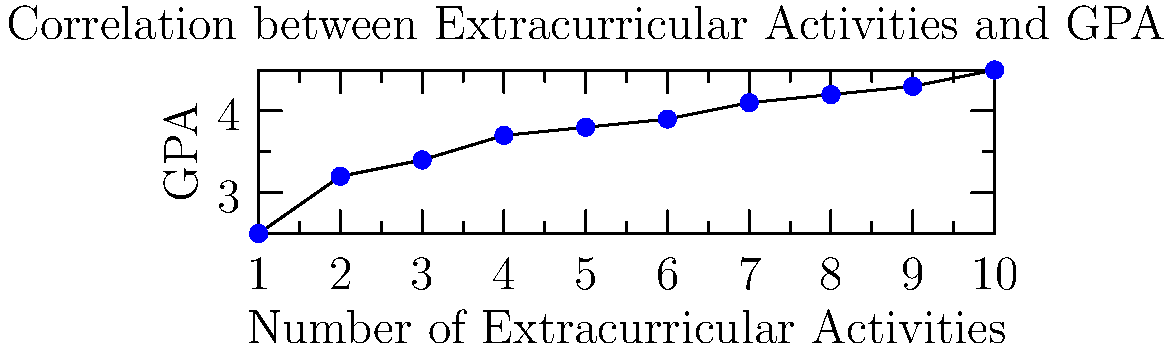As a school counselor analyzing the impact of popular culture on student behavior, you come across a scatter plot showing the relationship between the number of extracurricular activities students participate in and their GPA. Based on the scatter plot, what can you conclude about the correlation between extracurricular involvement and academic performance? To analyze the correlation between extracurricular activities and academic performance, we need to examine the scatter plot:

1. Observe the overall trend: As we move from left to right (increasing number of extracurricular activities), we see that the GPA points generally move upward.

2. Identify the pattern: The points form a relatively linear pattern, moving from the bottom-left to the top-right of the graph.

3. Assess the strength: The points are fairly close to an imaginary line that could be drawn through them, indicating a moderately strong relationship.

4. Determine the direction: As the number of extracurricular activities increases, the GPA tends to increase as well, showing a positive correlation.

5. Consider outliers: There don't appear to be any significant outliers that would skew the relationship.

6. Interpret the results: This positive correlation suggests that students who participate in more extracurricular activities tend to have higher GPAs. However, it's important to note that correlation does not imply causation.

7. Reflect on the implications: As a school counselor, this data might inform discussions about the potential benefits of extracurricular involvement on academic performance, while also considering other factors that might influence this relationship.
Answer: Positive correlation between extracurricular activities and GPA 